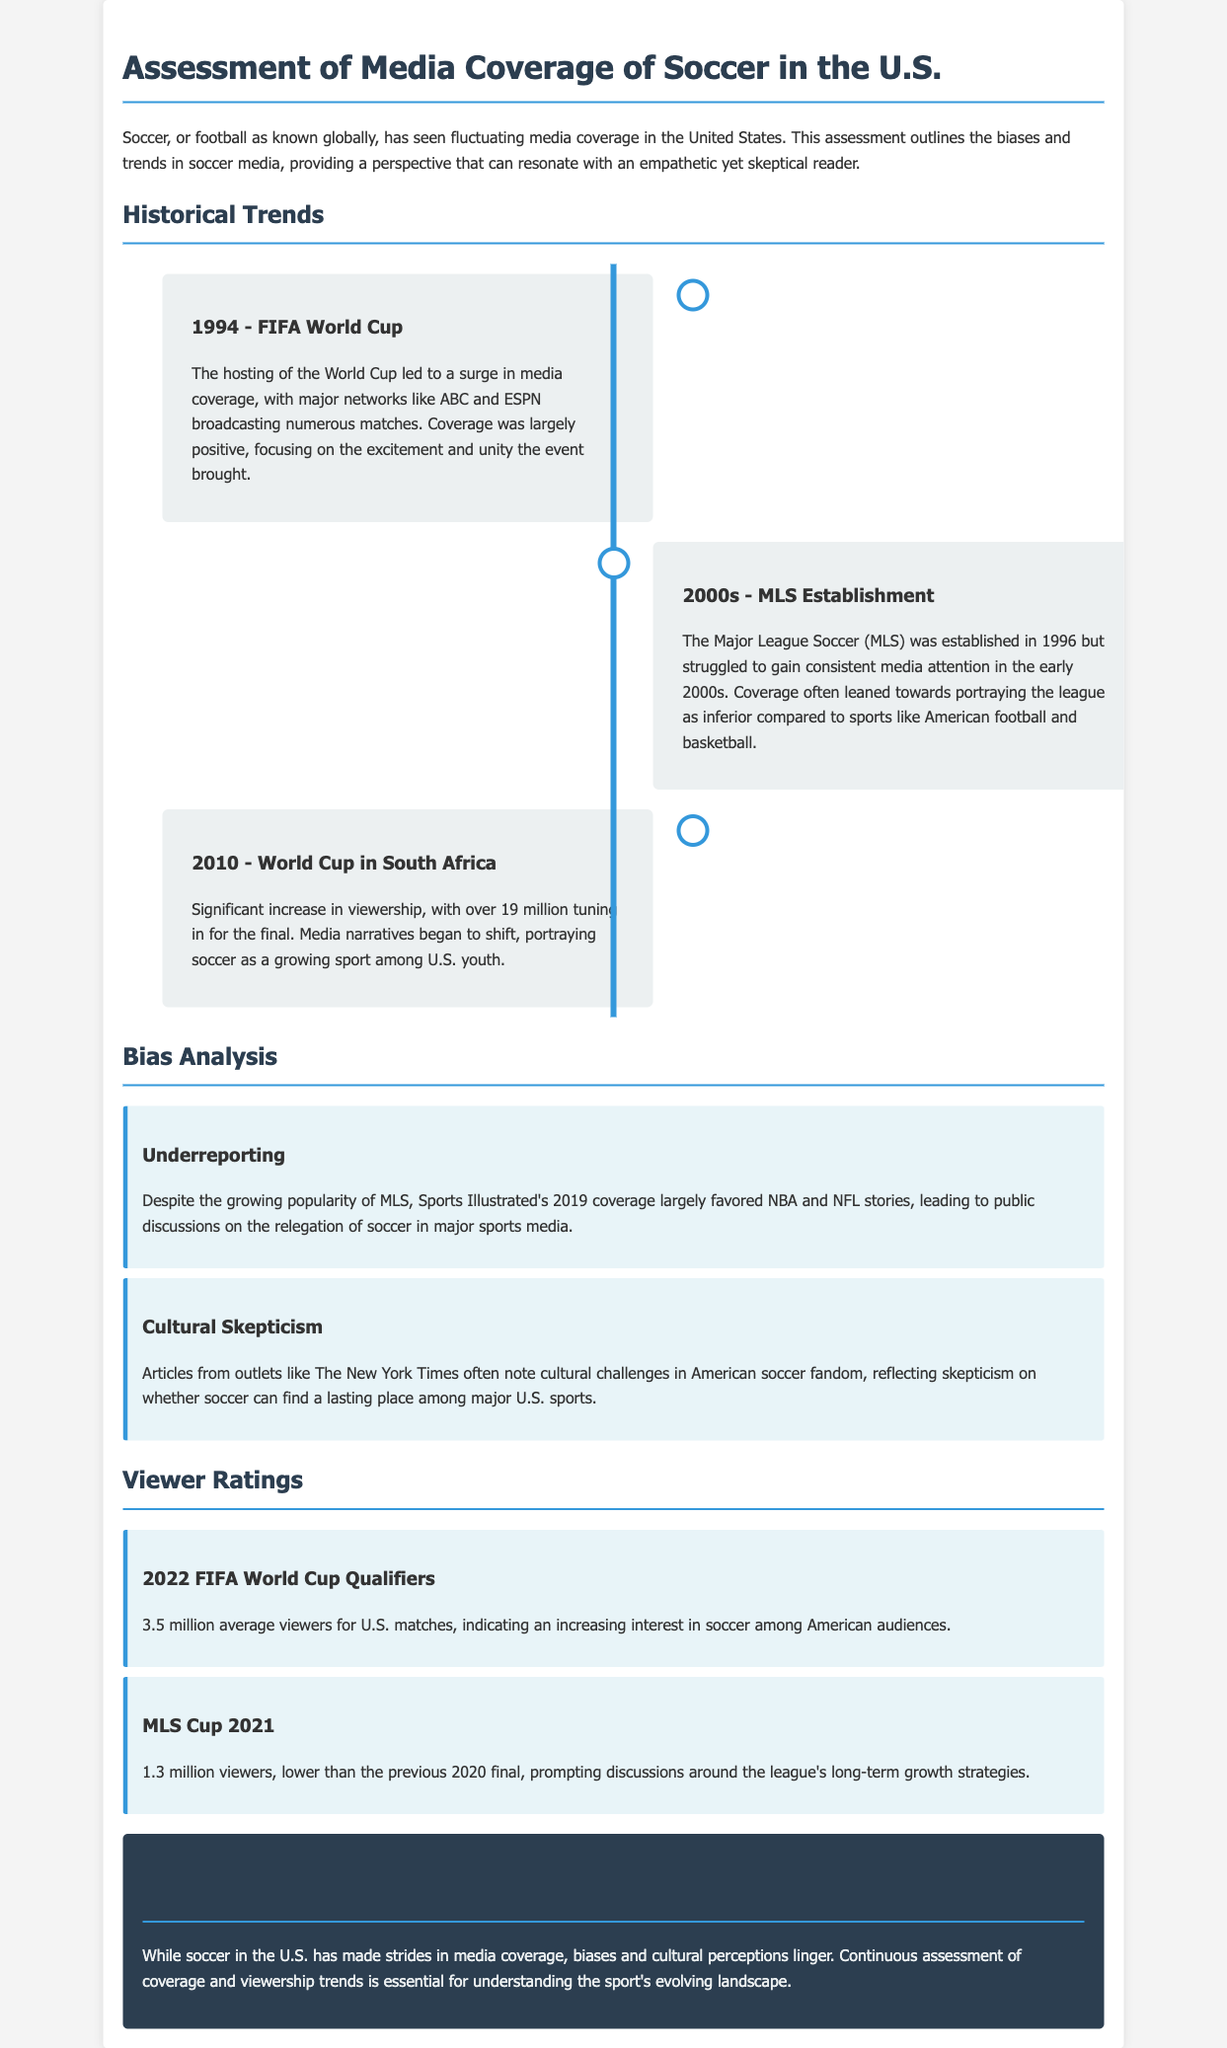What year did the FIFA World Cup take place in the U.S.? The text states that the FIFA World Cup was hosted in the U.S. in 1994.
Answer: 1994 How many viewers tuned in for the final of the 2010 World Cup? The document indicates that over 19 million viewers watched the final of the 2010 World Cup in South Africa.
Answer: Over 19 million Which league's establishment struggled for consistent media attention in the early 2000s? According to the content, Major League Soccer (MLS) struggled for media attention during the early 2000s.
Answer: Major League Soccer (MLS) What trend is highlighted by viewer ratings for the MLS Cup in 2021? The document mentions that the MLS Cup 2021 had 1.3 million viewers, lower than the previous year's final, indicating a discussion about the league's growth.
Answer: Lower viewership What cultural challenge is mentioned regarding American soccer fandom? The document notes skepticism on whether soccer can find a lasting place among major U.S. sports, reflecting cultural challenges.
Answer: Cultural skepticism 